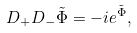<formula> <loc_0><loc_0><loc_500><loc_500>D _ { + } D _ { - } \tilde { \Phi } = - i e ^ { \tilde { \Phi } } ,</formula> 